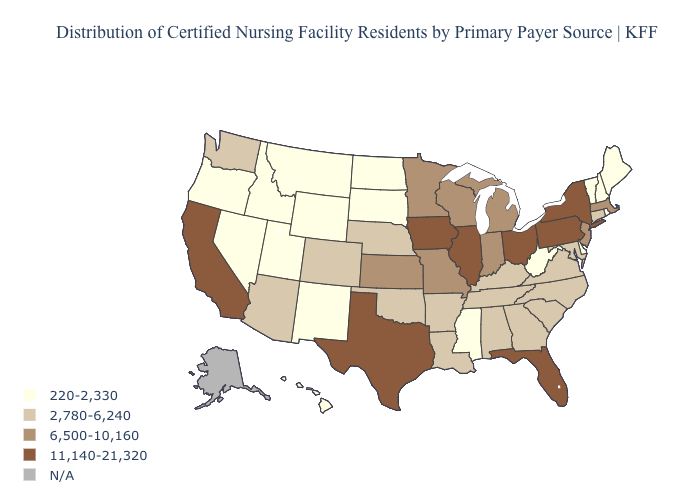What is the value of Montana?
Write a very short answer. 220-2,330. Name the states that have a value in the range 6,500-10,160?
Keep it brief. Indiana, Kansas, Massachusetts, Michigan, Minnesota, Missouri, New Jersey, Wisconsin. Name the states that have a value in the range 2,780-6,240?
Be succinct. Alabama, Arizona, Arkansas, Colorado, Connecticut, Georgia, Kentucky, Louisiana, Maryland, Nebraska, North Carolina, Oklahoma, South Carolina, Tennessee, Virginia, Washington. Name the states that have a value in the range 2,780-6,240?
Write a very short answer. Alabama, Arizona, Arkansas, Colorado, Connecticut, Georgia, Kentucky, Louisiana, Maryland, Nebraska, North Carolina, Oklahoma, South Carolina, Tennessee, Virginia, Washington. What is the value of Indiana?
Answer briefly. 6,500-10,160. Name the states that have a value in the range 11,140-21,320?
Short answer required. California, Florida, Illinois, Iowa, New York, Ohio, Pennsylvania, Texas. Name the states that have a value in the range N/A?
Be succinct. Alaska. Name the states that have a value in the range N/A?
Quick response, please. Alaska. Among the states that border Kansas , which have the lowest value?
Short answer required. Colorado, Nebraska, Oklahoma. What is the highest value in states that border West Virginia?
Write a very short answer. 11,140-21,320. Among the states that border Nebraska , does Kansas have the highest value?
Give a very brief answer. No. Which states have the highest value in the USA?
Write a very short answer. California, Florida, Illinois, Iowa, New York, Ohio, Pennsylvania, Texas. What is the value of Wisconsin?
Write a very short answer. 6,500-10,160. Does the map have missing data?
Answer briefly. Yes. 